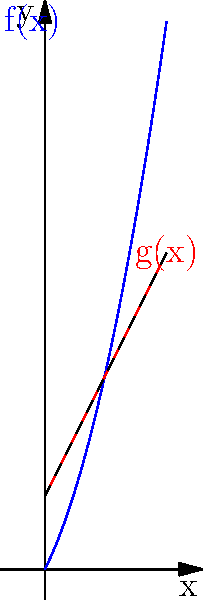In the context of accumulating positive workplace experiences, let $f(x)$ represent the cumulative positive impact over time $x$ (in months), and $g(x)$ represent a linear approximation of this growth. Given $f(x) = 0.5x^2 + 2x$ and $g(x) = 2x + 3$, calculate the total additional positive impact gained by following the actual growth curve $f(x)$ instead of the linear approximation $g(x)$ over a 5-month period. To solve this problem, we need to follow these steps:

1) The additional positive impact is represented by the area between $f(x)$ and $g(x)$ from $x=0$ to $x=5$.

2) We can calculate this area by integrating the difference between $f(x)$ and $g(x)$:

   $$\int_0^5 [f(x) - g(x)] dx$$

3) Substitute the functions:

   $$\int_0^5 [(0.5x^2 + 2x) - (2x + 3)] dx$$

4) Simplify:

   $$\int_0^5 (0.5x^2 - 3) dx$$

5) Integrate:

   $$[0.5 \cdot \frac{x^3}{3} - 3x]_0^5$$

6) Evaluate the definite integral:

   $$(0.5 \cdot \frac{5^3}{3} - 3 \cdot 5) - (0.5 \cdot \frac{0^3}{3} - 3 \cdot 0)$$

7) Calculate:

   $$(\frac{125}{6} - 15) - 0 = \frac{125}{6} - 15 = \frac{125}{6} - \frac{90}{6} = \frac{35}{6}$$

Therefore, the total additional positive impact gained over the 5-month period is $\frac{35}{6}$ units.
Answer: $\frac{35}{6}$ units 